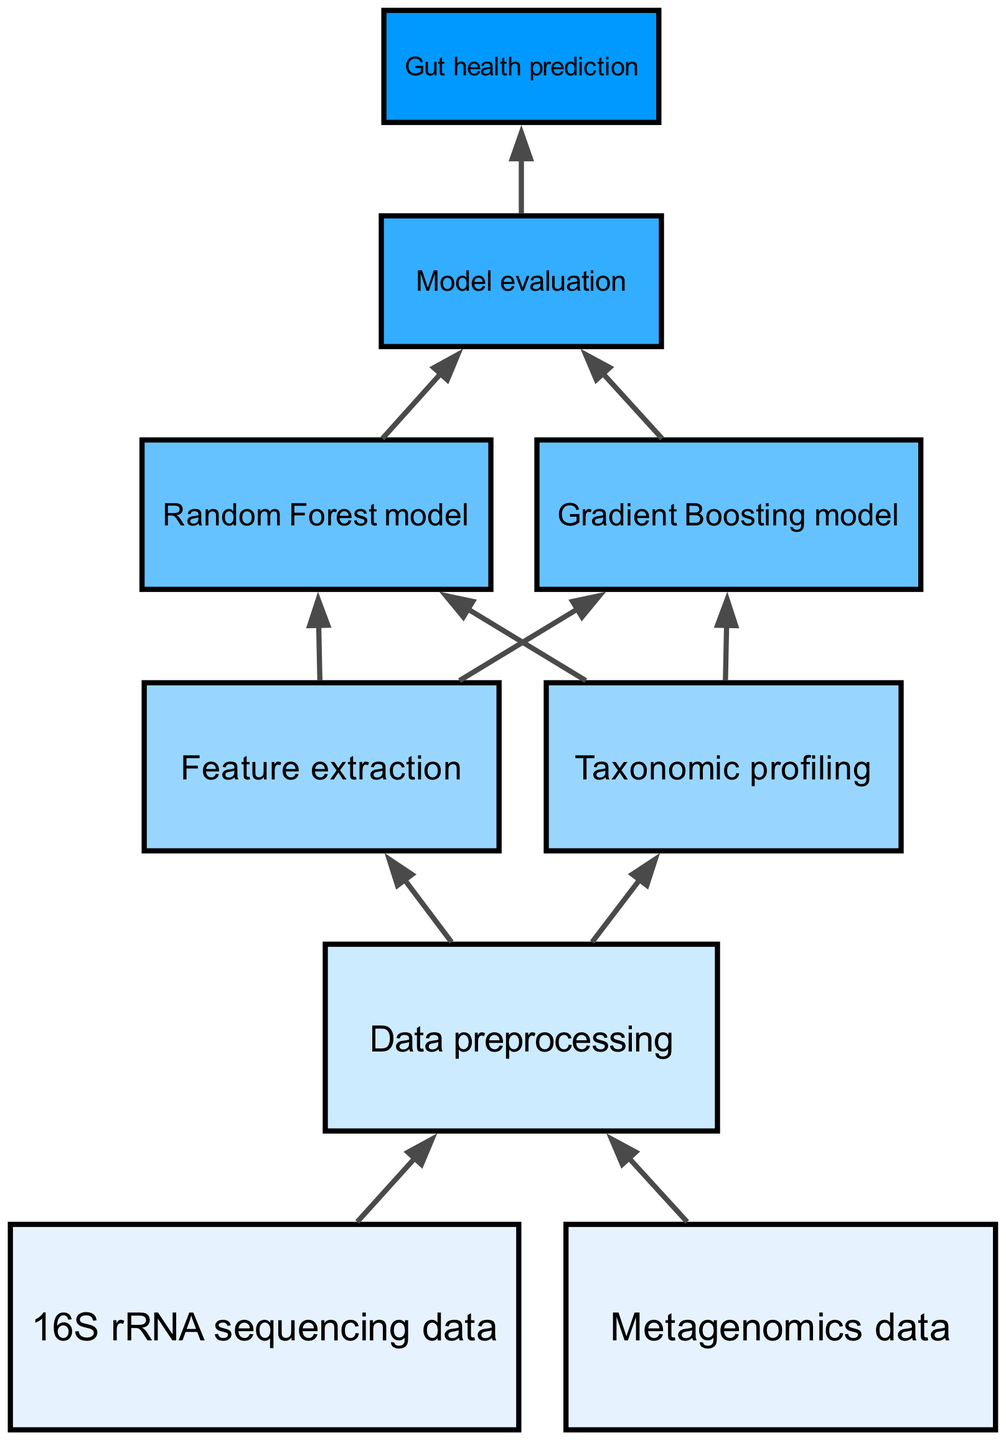What are the two types of data inputs in this flow chart? The diagram illustrates two main types of input data at level 1: 16S rRNA sequencing data and Metagenomics data. This can be determined by looking at the two nodes at the top of the chart.
Answer: 16S rRNA sequencing data, Metagenomics data What is the third step in the flow chart? The third step in the flow chart is Data preprocessing, which is indicated as the node connected from both types of data inputs. It is the first process that occurs after gathering the data.
Answer: Data preprocessing How many models are used for prediction after feature extraction? After feature extraction, two models are utilized for prediction: the Random Forest model and the Gradient Boosting model. This can be seen from the connections stemming from the feature extraction node leading to both models.
Answer: Two What is the final outcome of the entire process shown in the diagram? The final outcome of the flow chart is Gut health prediction. It is positioned as the last node in the diagram and is reached after the Model evaluation step.
Answer: Gut health prediction What level is the Feature extraction step located at in the diagram? Feature extraction is located at level 3 in the flow chart. This can be identified by checking the node levels assigned in the diagram data.
Answer: Level 3 What nodes directly connect to the Data preprocessing node? The Data preprocessing node connects directly to two nodes: Feature extraction and Taxonomic profiling. This can be seen from the branching connections leading from the Data preprocessing node.
Answer: Feature extraction, Taxonomic profiling How many total edges are present in the flow chart? In total, there are 10 edges connecting the various nodes in the flow chart. This can be verified by counting each connection represented visually in the diagram.
Answer: Ten Which node comes after Model evaluation? The node that follows Model evaluation is Gut health prediction. This relationship can be traced directly from the connections outlined in the flow chart.
Answer: Gut health prediction 